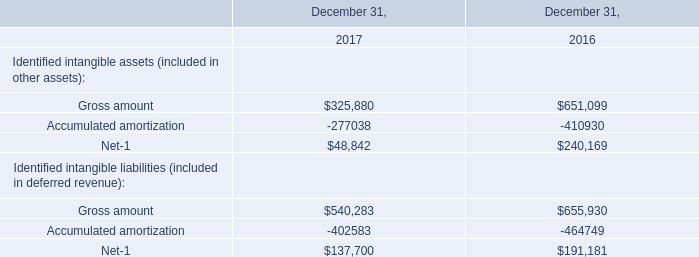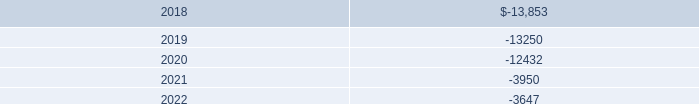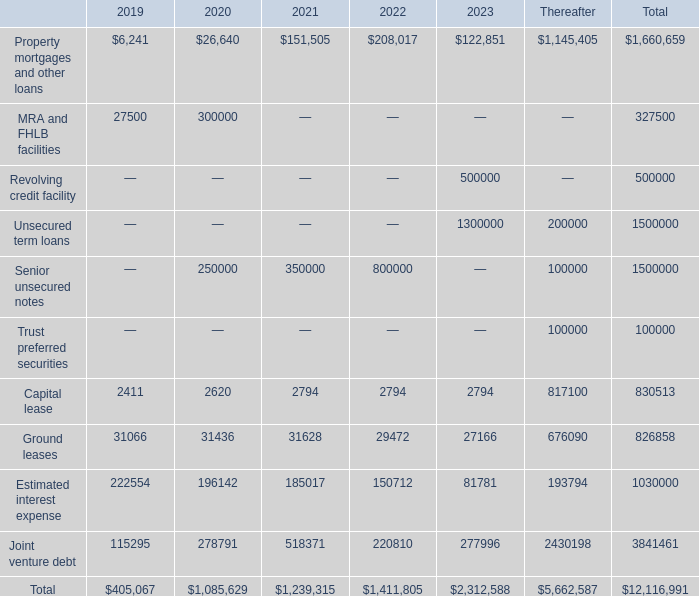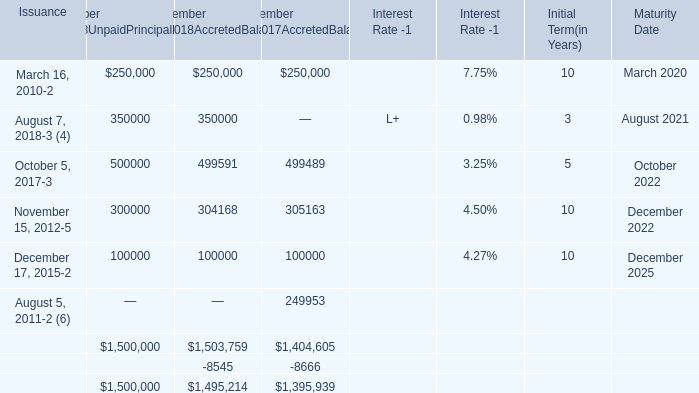what's the total amount of Gross amount of December 31, 2017, and December 17, 2015 of December 31,2018UnpaidPrincipalBalance ? 
Computations: (325880.0 + 100000.0)
Answer: 425880.0. 